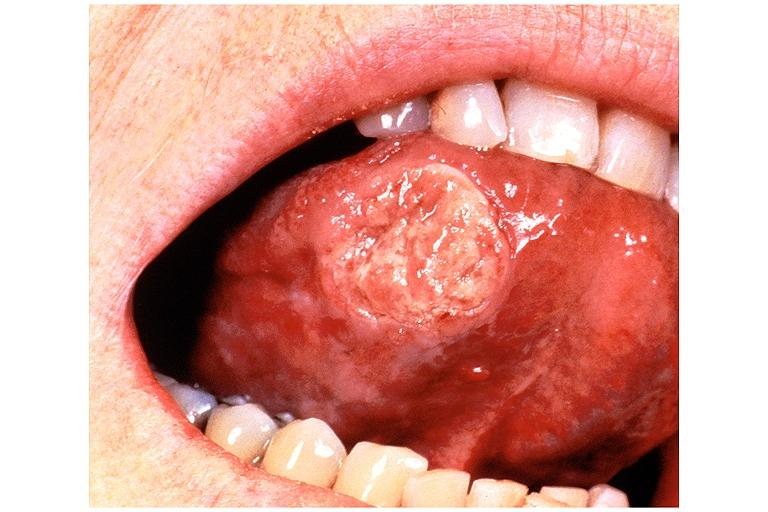s oral present?
Answer the question using a single word or phrase. Yes 